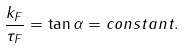<formula> <loc_0><loc_0><loc_500><loc_500>\frac { k _ { F } } { \tau _ { F } } = \tan \alpha = c o n s t a n t .</formula> 